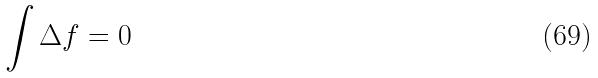<formula> <loc_0><loc_0><loc_500><loc_500>\int \Delta f = 0</formula> 